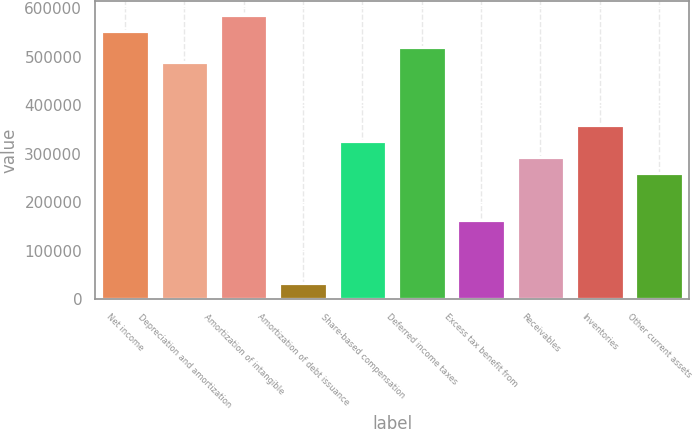<chart> <loc_0><loc_0><loc_500><loc_500><bar_chart><fcel>Net income<fcel>Depreciation and amortization<fcel>Amortization of intangible<fcel>Amortization of debt issuance<fcel>Share-based compensation<fcel>Deferred income taxes<fcel>Excess tax benefit from<fcel>Receivables<fcel>Inventories<fcel>Other current assets<nl><fcel>553543<fcel>488582<fcel>586023<fcel>33856.4<fcel>326180<fcel>521062<fcel>163778<fcel>293700<fcel>358660<fcel>261219<nl></chart> 